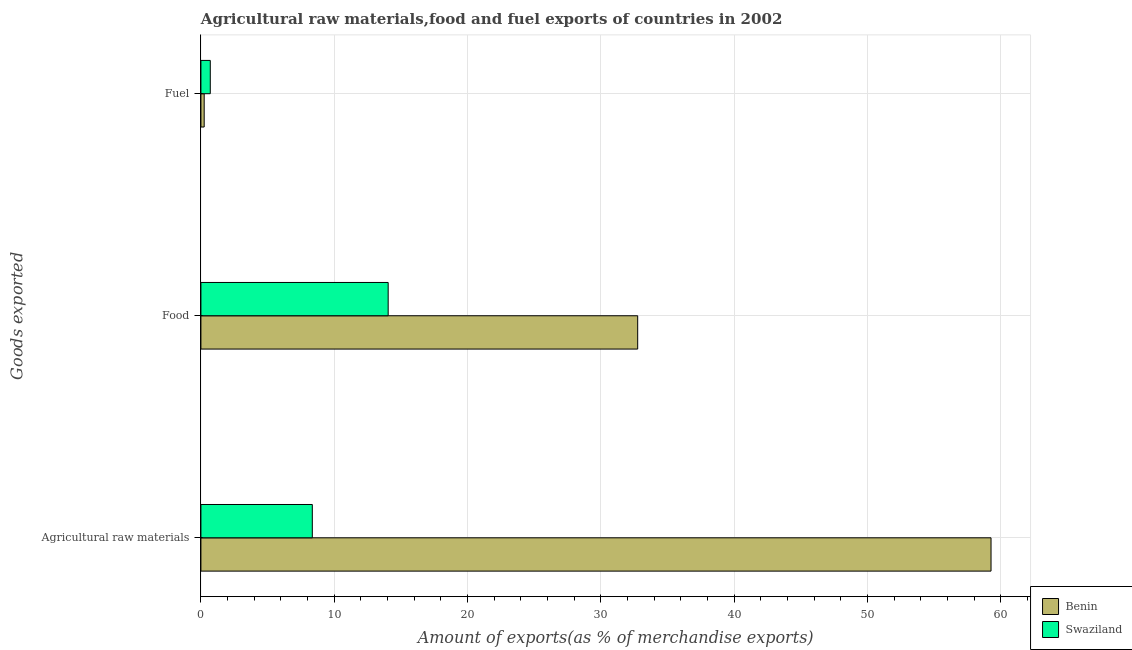How many different coloured bars are there?
Keep it short and to the point. 2. How many groups of bars are there?
Ensure brevity in your answer.  3. How many bars are there on the 1st tick from the bottom?
Your answer should be very brief. 2. What is the label of the 1st group of bars from the top?
Keep it short and to the point. Fuel. What is the percentage of fuel exports in Benin?
Offer a very short reply. 0.25. Across all countries, what is the maximum percentage of fuel exports?
Ensure brevity in your answer.  0.7. Across all countries, what is the minimum percentage of food exports?
Offer a very short reply. 14.04. In which country was the percentage of raw materials exports maximum?
Provide a succinct answer. Benin. In which country was the percentage of food exports minimum?
Your answer should be very brief. Swaziland. What is the total percentage of fuel exports in the graph?
Keep it short and to the point. 0.95. What is the difference between the percentage of raw materials exports in Benin and that in Swaziland?
Your answer should be very brief. 50.9. What is the difference between the percentage of raw materials exports in Swaziland and the percentage of fuel exports in Benin?
Keep it short and to the point. 8.11. What is the average percentage of raw materials exports per country?
Provide a succinct answer. 33.8. What is the difference between the percentage of raw materials exports and percentage of fuel exports in Swaziland?
Provide a succinct answer. 7.65. In how many countries, is the percentage of raw materials exports greater than 28 %?
Give a very brief answer. 1. What is the ratio of the percentage of food exports in Swaziland to that in Benin?
Offer a very short reply. 0.43. Is the percentage of raw materials exports in Benin less than that in Swaziland?
Provide a short and direct response. No. What is the difference between the highest and the second highest percentage of raw materials exports?
Ensure brevity in your answer.  50.9. What is the difference between the highest and the lowest percentage of food exports?
Provide a succinct answer. 18.71. Is the sum of the percentage of raw materials exports in Swaziland and Benin greater than the maximum percentage of food exports across all countries?
Your answer should be very brief. Yes. What does the 1st bar from the top in Fuel represents?
Your answer should be compact. Swaziland. What does the 1st bar from the bottom in Fuel represents?
Your answer should be compact. Benin. Is it the case that in every country, the sum of the percentage of raw materials exports and percentage of food exports is greater than the percentage of fuel exports?
Give a very brief answer. Yes. How many bars are there?
Provide a short and direct response. 6. What is the difference between two consecutive major ticks on the X-axis?
Give a very brief answer. 10. Does the graph contain grids?
Your response must be concise. Yes. Where does the legend appear in the graph?
Provide a short and direct response. Bottom right. How are the legend labels stacked?
Your answer should be compact. Vertical. What is the title of the graph?
Keep it short and to the point. Agricultural raw materials,food and fuel exports of countries in 2002. What is the label or title of the X-axis?
Ensure brevity in your answer.  Amount of exports(as % of merchandise exports). What is the label or title of the Y-axis?
Give a very brief answer. Goods exported. What is the Amount of exports(as % of merchandise exports) of Benin in Agricultural raw materials?
Ensure brevity in your answer.  59.25. What is the Amount of exports(as % of merchandise exports) of Swaziland in Agricultural raw materials?
Your response must be concise. 8.35. What is the Amount of exports(as % of merchandise exports) of Benin in Food?
Your answer should be compact. 32.76. What is the Amount of exports(as % of merchandise exports) in Swaziland in Food?
Offer a terse response. 14.04. What is the Amount of exports(as % of merchandise exports) of Benin in Fuel?
Provide a succinct answer. 0.25. What is the Amount of exports(as % of merchandise exports) in Swaziland in Fuel?
Keep it short and to the point. 0.7. Across all Goods exported, what is the maximum Amount of exports(as % of merchandise exports) of Benin?
Your answer should be very brief. 59.25. Across all Goods exported, what is the maximum Amount of exports(as % of merchandise exports) of Swaziland?
Offer a terse response. 14.04. Across all Goods exported, what is the minimum Amount of exports(as % of merchandise exports) of Benin?
Offer a terse response. 0.25. Across all Goods exported, what is the minimum Amount of exports(as % of merchandise exports) in Swaziland?
Your response must be concise. 0.7. What is the total Amount of exports(as % of merchandise exports) of Benin in the graph?
Ensure brevity in your answer.  92.26. What is the total Amount of exports(as % of merchandise exports) in Swaziland in the graph?
Make the answer very short. 23.1. What is the difference between the Amount of exports(as % of merchandise exports) in Benin in Agricultural raw materials and that in Food?
Offer a terse response. 26.5. What is the difference between the Amount of exports(as % of merchandise exports) of Swaziland in Agricultural raw materials and that in Food?
Your answer should be very brief. -5.69. What is the difference between the Amount of exports(as % of merchandise exports) in Benin in Agricultural raw materials and that in Fuel?
Offer a very short reply. 59.01. What is the difference between the Amount of exports(as % of merchandise exports) in Swaziland in Agricultural raw materials and that in Fuel?
Keep it short and to the point. 7.65. What is the difference between the Amount of exports(as % of merchandise exports) of Benin in Food and that in Fuel?
Offer a very short reply. 32.51. What is the difference between the Amount of exports(as % of merchandise exports) in Swaziland in Food and that in Fuel?
Keep it short and to the point. 13.34. What is the difference between the Amount of exports(as % of merchandise exports) in Benin in Agricultural raw materials and the Amount of exports(as % of merchandise exports) in Swaziland in Food?
Your response must be concise. 45.21. What is the difference between the Amount of exports(as % of merchandise exports) in Benin in Agricultural raw materials and the Amount of exports(as % of merchandise exports) in Swaziland in Fuel?
Make the answer very short. 58.55. What is the difference between the Amount of exports(as % of merchandise exports) in Benin in Food and the Amount of exports(as % of merchandise exports) in Swaziland in Fuel?
Your response must be concise. 32.05. What is the average Amount of exports(as % of merchandise exports) of Benin per Goods exported?
Provide a succinct answer. 30.75. What is the average Amount of exports(as % of merchandise exports) in Swaziland per Goods exported?
Keep it short and to the point. 7.7. What is the difference between the Amount of exports(as % of merchandise exports) of Benin and Amount of exports(as % of merchandise exports) of Swaziland in Agricultural raw materials?
Provide a short and direct response. 50.9. What is the difference between the Amount of exports(as % of merchandise exports) of Benin and Amount of exports(as % of merchandise exports) of Swaziland in Food?
Your answer should be compact. 18.71. What is the difference between the Amount of exports(as % of merchandise exports) in Benin and Amount of exports(as % of merchandise exports) in Swaziland in Fuel?
Offer a very short reply. -0.46. What is the ratio of the Amount of exports(as % of merchandise exports) in Benin in Agricultural raw materials to that in Food?
Provide a short and direct response. 1.81. What is the ratio of the Amount of exports(as % of merchandise exports) of Swaziland in Agricultural raw materials to that in Food?
Give a very brief answer. 0.59. What is the ratio of the Amount of exports(as % of merchandise exports) in Benin in Agricultural raw materials to that in Fuel?
Your response must be concise. 241.04. What is the ratio of the Amount of exports(as % of merchandise exports) of Swaziland in Agricultural raw materials to that in Fuel?
Your response must be concise. 11.89. What is the ratio of the Amount of exports(as % of merchandise exports) in Benin in Food to that in Fuel?
Make the answer very short. 133.25. What is the ratio of the Amount of exports(as % of merchandise exports) in Swaziland in Food to that in Fuel?
Keep it short and to the point. 19.99. What is the difference between the highest and the second highest Amount of exports(as % of merchandise exports) of Benin?
Give a very brief answer. 26.5. What is the difference between the highest and the second highest Amount of exports(as % of merchandise exports) in Swaziland?
Offer a very short reply. 5.69. What is the difference between the highest and the lowest Amount of exports(as % of merchandise exports) in Benin?
Make the answer very short. 59.01. What is the difference between the highest and the lowest Amount of exports(as % of merchandise exports) in Swaziland?
Provide a succinct answer. 13.34. 